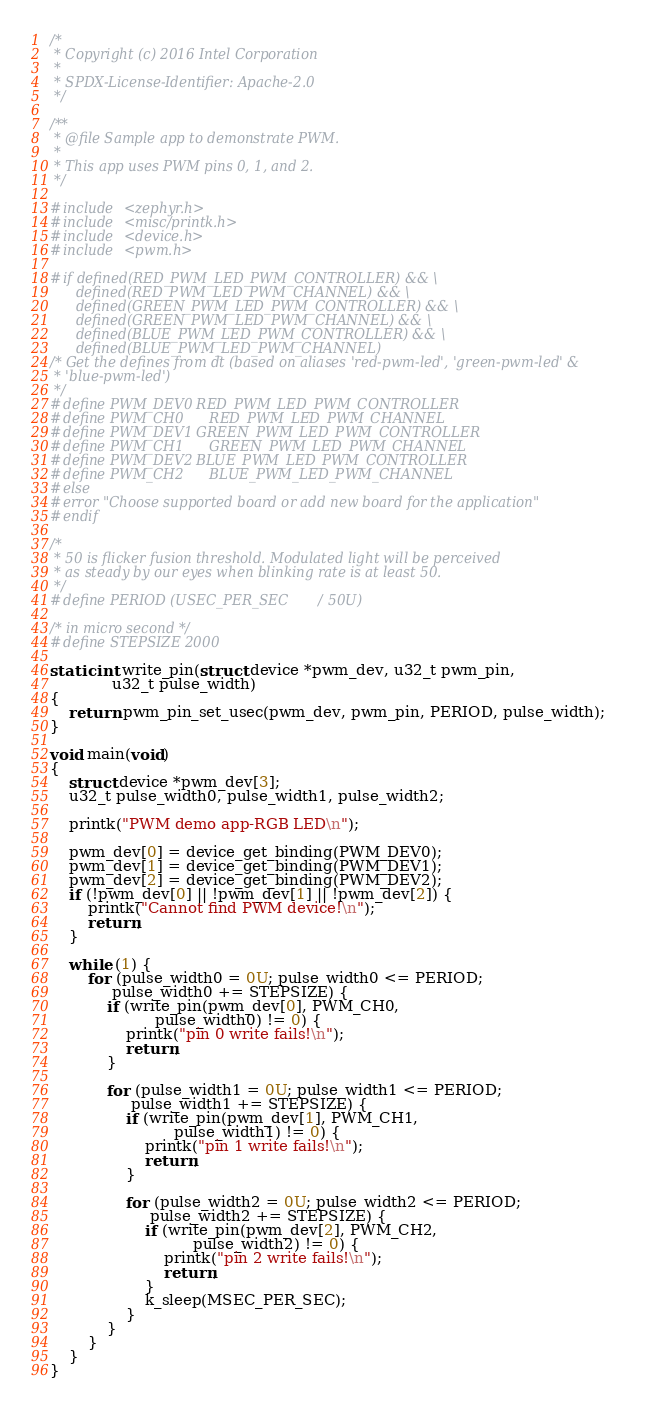<code> <loc_0><loc_0><loc_500><loc_500><_C_>/*
 * Copyright (c) 2016 Intel Corporation
 *
 * SPDX-License-Identifier: Apache-2.0
 */

/**
 * @file Sample app to demonstrate PWM.
 *
 * This app uses PWM pins 0, 1, and 2.
 */

#include <zephyr.h>
#include <misc/printk.h>
#include <device.h>
#include <pwm.h>

#if defined(RED_PWM_LED_PWM_CONTROLLER) && \
      defined(RED_PWM_LED_PWM_CHANNEL) && \
      defined(GREEN_PWM_LED_PWM_CONTROLLER) && \
      defined(GREEN_PWM_LED_PWM_CHANNEL) && \
      defined(BLUE_PWM_LED_PWM_CONTROLLER) && \
      defined(BLUE_PWM_LED_PWM_CHANNEL)
/* Get the defines from dt (based on aliases 'red-pwm-led', 'green-pwm-led' &
 * 'blue-pwm-led')
 */
#define PWM_DEV0	RED_PWM_LED_PWM_CONTROLLER
#define PWM_CH0		RED_PWM_LED_PWM_CHANNEL
#define PWM_DEV1	GREEN_PWM_LED_PWM_CONTROLLER
#define PWM_CH1		GREEN_PWM_LED_PWM_CHANNEL
#define PWM_DEV2	BLUE_PWM_LED_PWM_CONTROLLER
#define PWM_CH2		BLUE_PWM_LED_PWM_CHANNEL
#else
#error "Choose supported board or add new board for the application"
#endif

/*
 * 50 is flicker fusion threshold. Modulated light will be perceived
 * as steady by our eyes when blinking rate is at least 50.
 */
#define PERIOD (USEC_PER_SEC / 50U)

/* in micro second */
#define STEPSIZE	2000

static int write_pin(struct device *pwm_dev, u32_t pwm_pin,
		     u32_t pulse_width)
{
	return pwm_pin_set_usec(pwm_dev, pwm_pin, PERIOD, pulse_width);
}

void main(void)
{
	struct device *pwm_dev[3];
	u32_t pulse_width0, pulse_width1, pulse_width2;

	printk("PWM demo app-RGB LED\n");

	pwm_dev[0] = device_get_binding(PWM_DEV0);
	pwm_dev[1] = device_get_binding(PWM_DEV1);
	pwm_dev[2] = device_get_binding(PWM_DEV2);
	if (!pwm_dev[0] || !pwm_dev[1] || !pwm_dev[2]) {
		printk("Cannot find PWM device!\n");
		return;
	}

	while (1) {
		for (pulse_width0 = 0U; pulse_width0 <= PERIOD;
		     pulse_width0 += STEPSIZE) {
			if (write_pin(pwm_dev[0], PWM_CH0,
				      pulse_width0) != 0) {
				printk("pin 0 write fails!\n");
				return;
			}

			for (pulse_width1 = 0U; pulse_width1 <= PERIOD;
			     pulse_width1 += STEPSIZE) {
				if (write_pin(pwm_dev[1], PWM_CH1,
					      pulse_width1) != 0) {
					printk("pin 1 write fails!\n");
					return;
				}

				for (pulse_width2 = 0U; pulse_width2 <= PERIOD;
				     pulse_width2 += STEPSIZE) {
					if (write_pin(pwm_dev[2], PWM_CH2,
						      pulse_width2) != 0) {
						printk("pin 2 write fails!\n");
						return;
					}
					k_sleep(MSEC_PER_SEC);
				}
			}
		}
	}
}
</code> 